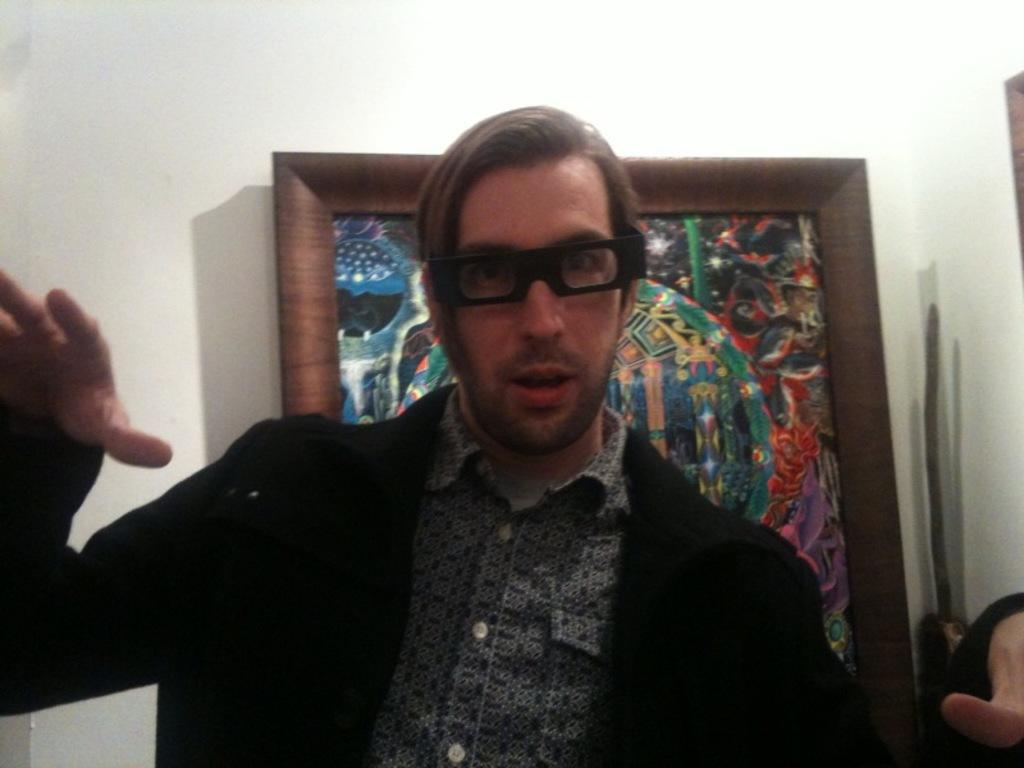What is the main subject of the image? There is a person in the image. What is the person wearing on their upper body? The person is wearing a black jacket and a shirt. What accessory is the person wearing in the image? The person is wearing spectacles. What is the person's posture in the image? The person is standing. What can be seen in the background of the image? There is a photo frame and a wall in the background of the image. What type of animals can be seen in the zoo in the image? There is no zoo present in the image; it features a person standing in front of a wall with a photo frame in the background. What holiday is the person celebrating in the image? There is no indication of a holiday being celebrated in the image. 